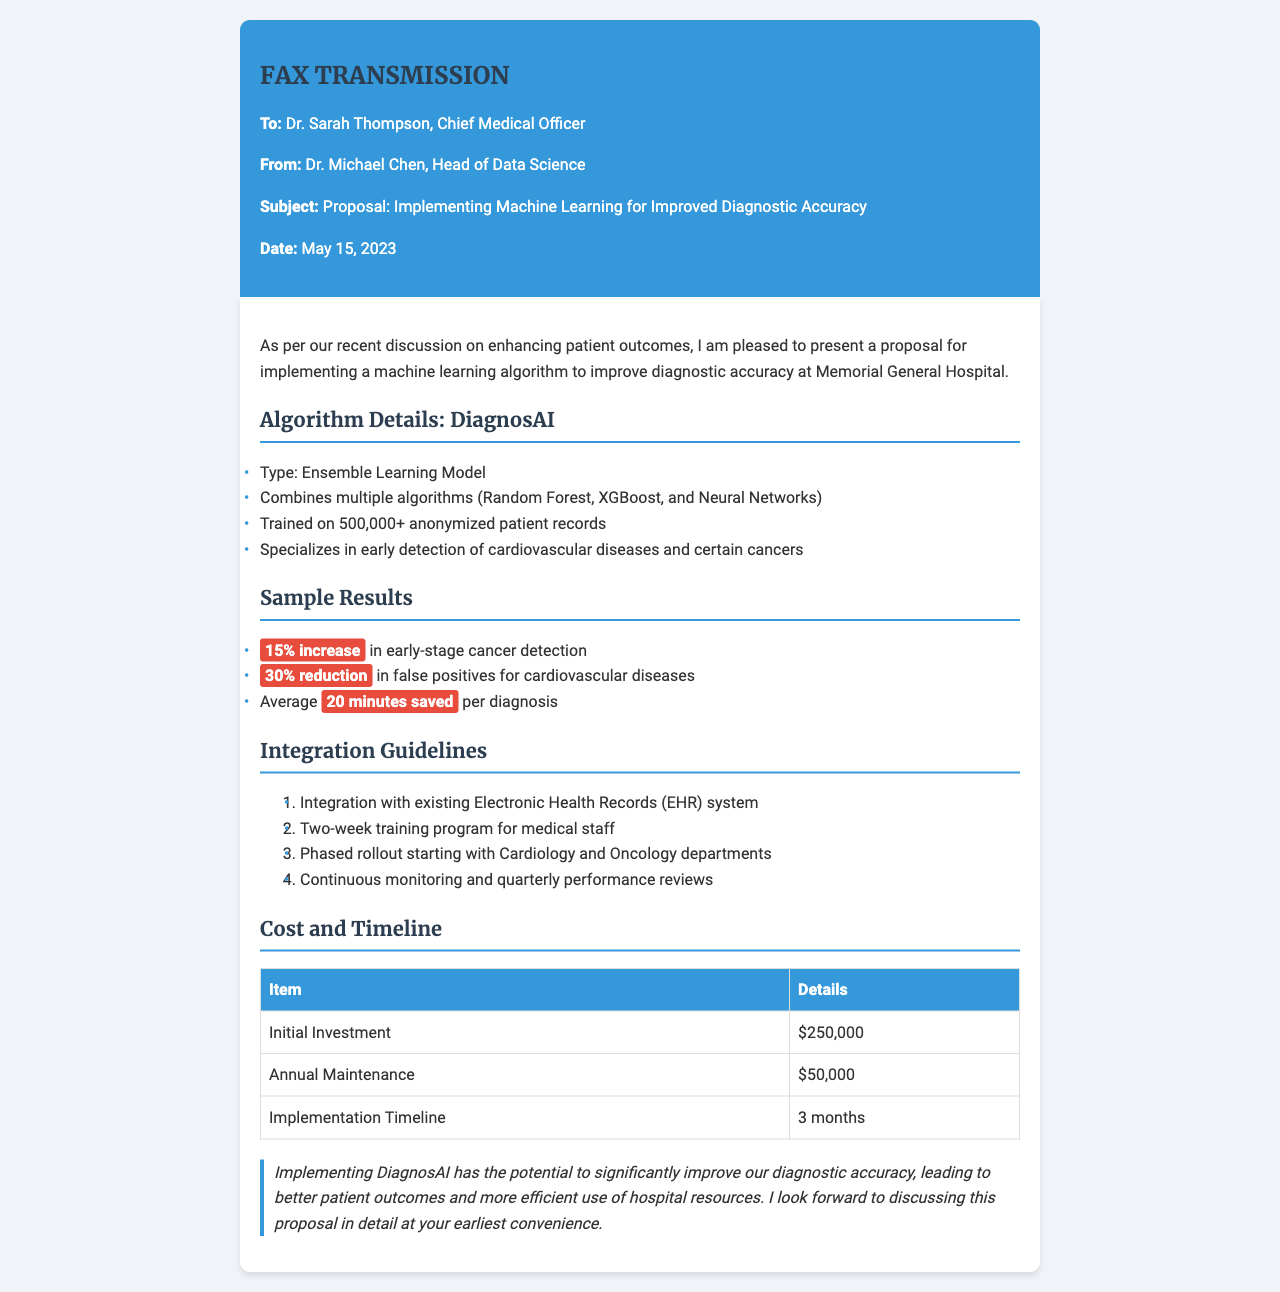What is the name of the machine learning algorithm proposed? The proposal mentions the name of the algorithm as "DiagnosAI."
Answer: DiagnosAI Who is the recipient of the fax? The fax is addressed to Dr. Sarah Thompson, the Chief Medical Officer.
Answer: Dr. Sarah Thompson What is the expected increase in early-stage cancer detection? The document states a "15% increase" in early-stage cancer detection.
Answer: 15% increase What is the initial investment required for implementation? The document lists the initial investment as $250,000.
Answer: $250,000 How long is the proposed training program for medical staff? The training program is proposed to last for two weeks.
Answer: Two weeks What are the two specialties targeted for the phased rollout? The integration guidelines specify starting with Cardiology and Oncology departments.
Answer: Cardiology and Oncology What is the annual maintenance cost? The document states that the annual maintenance cost is $50,000.
Answer: $50,000 How long is the implementation timeline? The proposed implementation timeline is 3 months.
Answer: 3 months What type of learning model is DiagnosAI based on? It is described as an "Ensemble Learning Model."
Answer: Ensemble Learning Model 